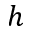<formula> <loc_0><loc_0><loc_500><loc_500>h</formula> 